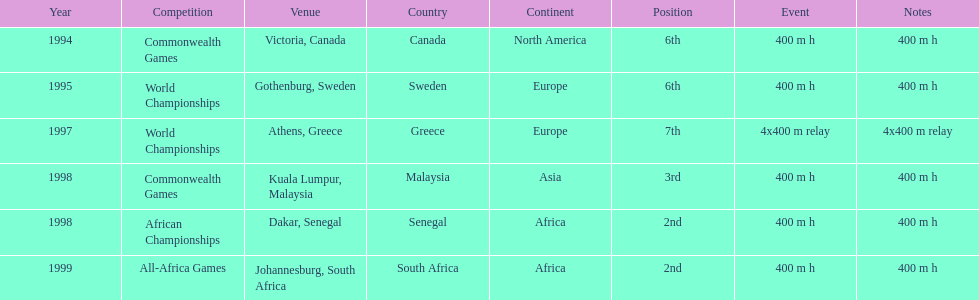Where was the next venue after athens, greece? Kuala Lumpur, Malaysia. 